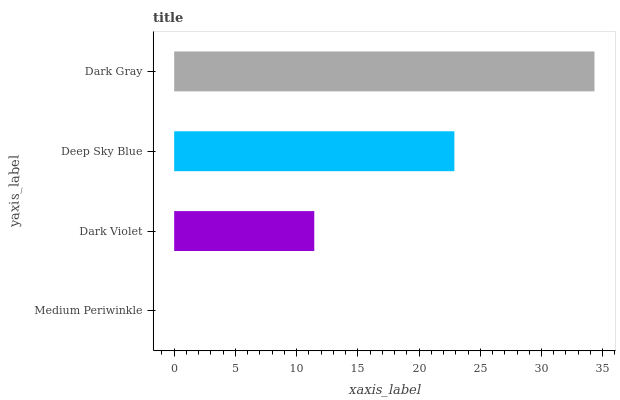Is Medium Periwinkle the minimum?
Answer yes or no. Yes. Is Dark Gray the maximum?
Answer yes or no. Yes. Is Dark Violet the minimum?
Answer yes or no. No. Is Dark Violet the maximum?
Answer yes or no. No. Is Dark Violet greater than Medium Periwinkle?
Answer yes or no. Yes. Is Medium Periwinkle less than Dark Violet?
Answer yes or no. Yes. Is Medium Periwinkle greater than Dark Violet?
Answer yes or no. No. Is Dark Violet less than Medium Periwinkle?
Answer yes or no. No. Is Deep Sky Blue the high median?
Answer yes or no. Yes. Is Dark Violet the low median?
Answer yes or no. Yes. Is Dark Violet the high median?
Answer yes or no. No. Is Medium Periwinkle the low median?
Answer yes or no. No. 